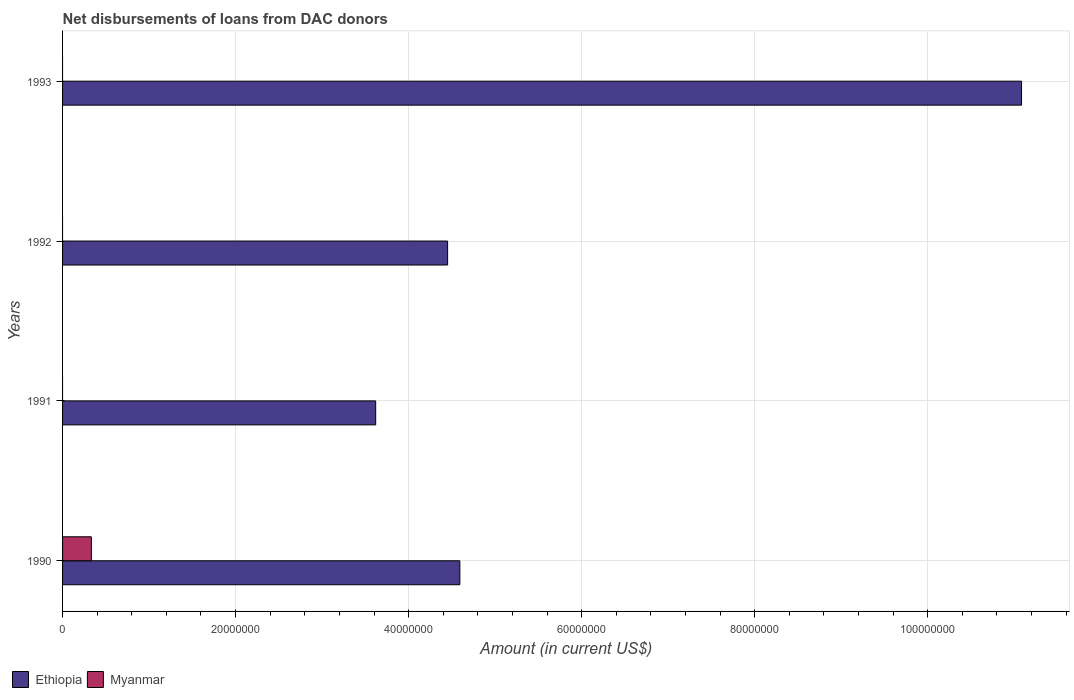Are the number of bars on each tick of the Y-axis equal?
Offer a very short reply. No. How many bars are there on the 1st tick from the bottom?
Make the answer very short. 2. What is the amount of loans disbursed in Myanmar in 1992?
Keep it short and to the point. 0. Across all years, what is the maximum amount of loans disbursed in Ethiopia?
Give a very brief answer. 1.11e+08. Across all years, what is the minimum amount of loans disbursed in Ethiopia?
Offer a terse response. 3.62e+07. What is the total amount of loans disbursed in Ethiopia in the graph?
Provide a short and direct response. 2.37e+08. What is the difference between the amount of loans disbursed in Ethiopia in 1991 and that in 1992?
Your response must be concise. -8.31e+06. What is the difference between the amount of loans disbursed in Myanmar in 1992 and the amount of loans disbursed in Ethiopia in 1993?
Make the answer very short. -1.11e+08. What is the average amount of loans disbursed in Ethiopia per year?
Make the answer very short. 5.94e+07. In the year 1990, what is the difference between the amount of loans disbursed in Ethiopia and amount of loans disbursed in Myanmar?
Ensure brevity in your answer.  4.26e+07. In how many years, is the amount of loans disbursed in Myanmar greater than 44000000 US$?
Ensure brevity in your answer.  0. What is the ratio of the amount of loans disbursed in Ethiopia in 1991 to that in 1992?
Your answer should be very brief. 0.81. What is the difference between the highest and the second highest amount of loans disbursed in Ethiopia?
Make the answer very short. 6.49e+07. What is the difference between the highest and the lowest amount of loans disbursed in Myanmar?
Give a very brief answer. 3.33e+06. Is the sum of the amount of loans disbursed in Ethiopia in 1990 and 1992 greater than the maximum amount of loans disbursed in Myanmar across all years?
Make the answer very short. Yes. Are all the bars in the graph horizontal?
Make the answer very short. Yes. How many years are there in the graph?
Offer a very short reply. 4. What is the difference between two consecutive major ticks on the X-axis?
Your answer should be very brief. 2.00e+07. Are the values on the major ticks of X-axis written in scientific E-notation?
Your answer should be very brief. No. What is the title of the graph?
Your answer should be compact. Net disbursements of loans from DAC donors. What is the Amount (in current US$) of Ethiopia in 1990?
Ensure brevity in your answer.  4.59e+07. What is the Amount (in current US$) of Myanmar in 1990?
Provide a succinct answer. 3.33e+06. What is the Amount (in current US$) in Ethiopia in 1991?
Offer a very short reply. 3.62e+07. What is the Amount (in current US$) in Myanmar in 1991?
Your response must be concise. 0. What is the Amount (in current US$) of Ethiopia in 1992?
Provide a succinct answer. 4.45e+07. What is the Amount (in current US$) in Ethiopia in 1993?
Provide a short and direct response. 1.11e+08. Across all years, what is the maximum Amount (in current US$) in Ethiopia?
Ensure brevity in your answer.  1.11e+08. Across all years, what is the maximum Amount (in current US$) in Myanmar?
Your answer should be very brief. 3.33e+06. Across all years, what is the minimum Amount (in current US$) of Ethiopia?
Your answer should be very brief. 3.62e+07. What is the total Amount (in current US$) of Ethiopia in the graph?
Offer a terse response. 2.37e+08. What is the total Amount (in current US$) of Myanmar in the graph?
Make the answer very short. 3.33e+06. What is the difference between the Amount (in current US$) in Ethiopia in 1990 and that in 1991?
Make the answer very short. 9.73e+06. What is the difference between the Amount (in current US$) in Ethiopia in 1990 and that in 1992?
Your answer should be compact. 1.41e+06. What is the difference between the Amount (in current US$) in Ethiopia in 1990 and that in 1993?
Keep it short and to the point. -6.49e+07. What is the difference between the Amount (in current US$) in Ethiopia in 1991 and that in 1992?
Your response must be concise. -8.31e+06. What is the difference between the Amount (in current US$) in Ethiopia in 1991 and that in 1993?
Your response must be concise. -7.47e+07. What is the difference between the Amount (in current US$) of Ethiopia in 1992 and that in 1993?
Your answer should be compact. -6.63e+07. What is the average Amount (in current US$) of Ethiopia per year?
Provide a succinct answer. 5.94e+07. What is the average Amount (in current US$) in Myanmar per year?
Keep it short and to the point. 8.32e+05. In the year 1990, what is the difference between the Amount (in current US$) of Ethiopia and Amount (in current US$) of Myanmar?
Keep it short and to the point. 4.26e+07. What is the ratio of the Amount (in current US$) of Ethiopia in 1990 to that in 1991?
Ensure brevity in your answer.  1.27. What is the ratio of the Amount (in current US$) in Ethiopia in 1990 to that in 1992?
Give a very brief answer. 1.03. What is the ratio of the Amount (in current US$) in Ethiopia in 1990 to that in 1993?
Your response must be concise. 0.41. What is the ratio of the Amount (in current US$) of Ethiopia in 1991 to that in 1992?
Your response must be concise. 0.81. What is the ratio of the Amount (in current US$) of Ethiopia in 1991 to that in 1993?
Your answer should be very brief. 0.33. What is the ratio of the Amount (in current US$) in Ethiopia in 1992 to that in 1993?
Your response must be concise. 0.4. What is the difference between the highest and the second highest Amount (in current US$) in Ethiopia?
Offer a terse response. 6.49e+07. What is the difference between the highest and the lowest Amount (in current US$) of Ethiopia?
Make the answer very short. 7.47e+07. What is the difference between the highest and the lowest Amount (in current US$) of Myanmar?
Provide a succinct answer. 3.33e+06. 